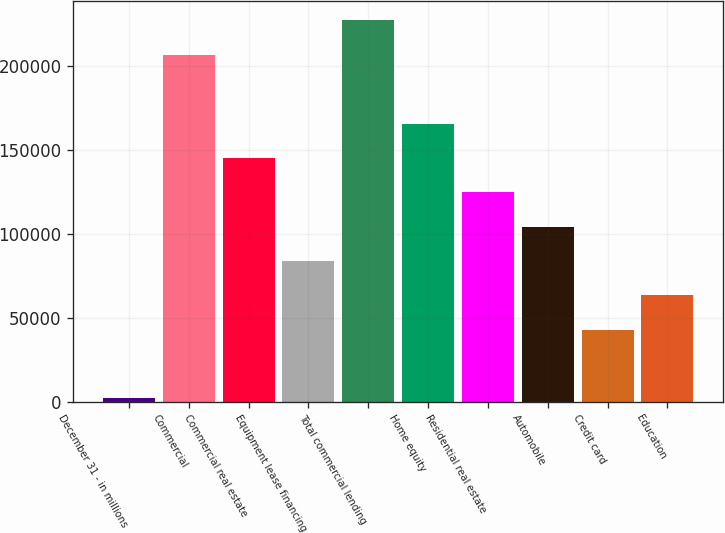<chart> <loc_0><loc_0><loc_500><loc_500><bar_chart><fcel>December 31 - in millions<fcel>Commercial<fcel>Commercial real estate<fcel>Equipment lease financing<fcel>Total commercial lending<fcel>Home equity<fcel>Residential real estate<fcel>Automobile<fcel>Credit card<fcel>Education<nl><fcel>2015<fcel>206696<fcel>145292<fcel>83887.4<fcel>227164<fcel>165760<fcel>124824<fcel>104356<fcel>42951.2<fcel>63419.3<nl></chart> 